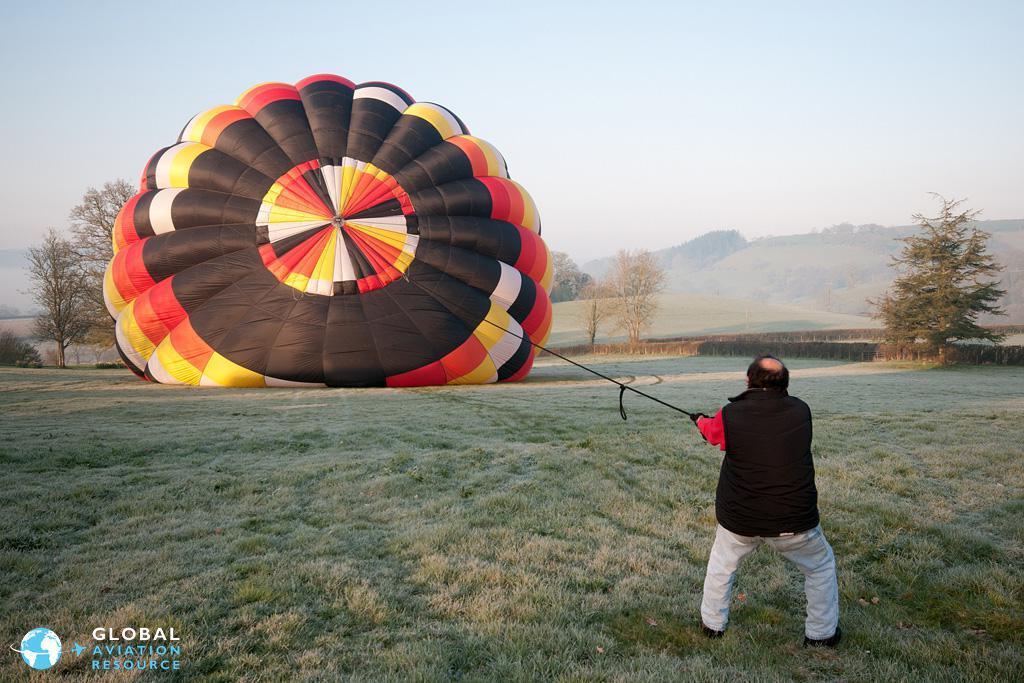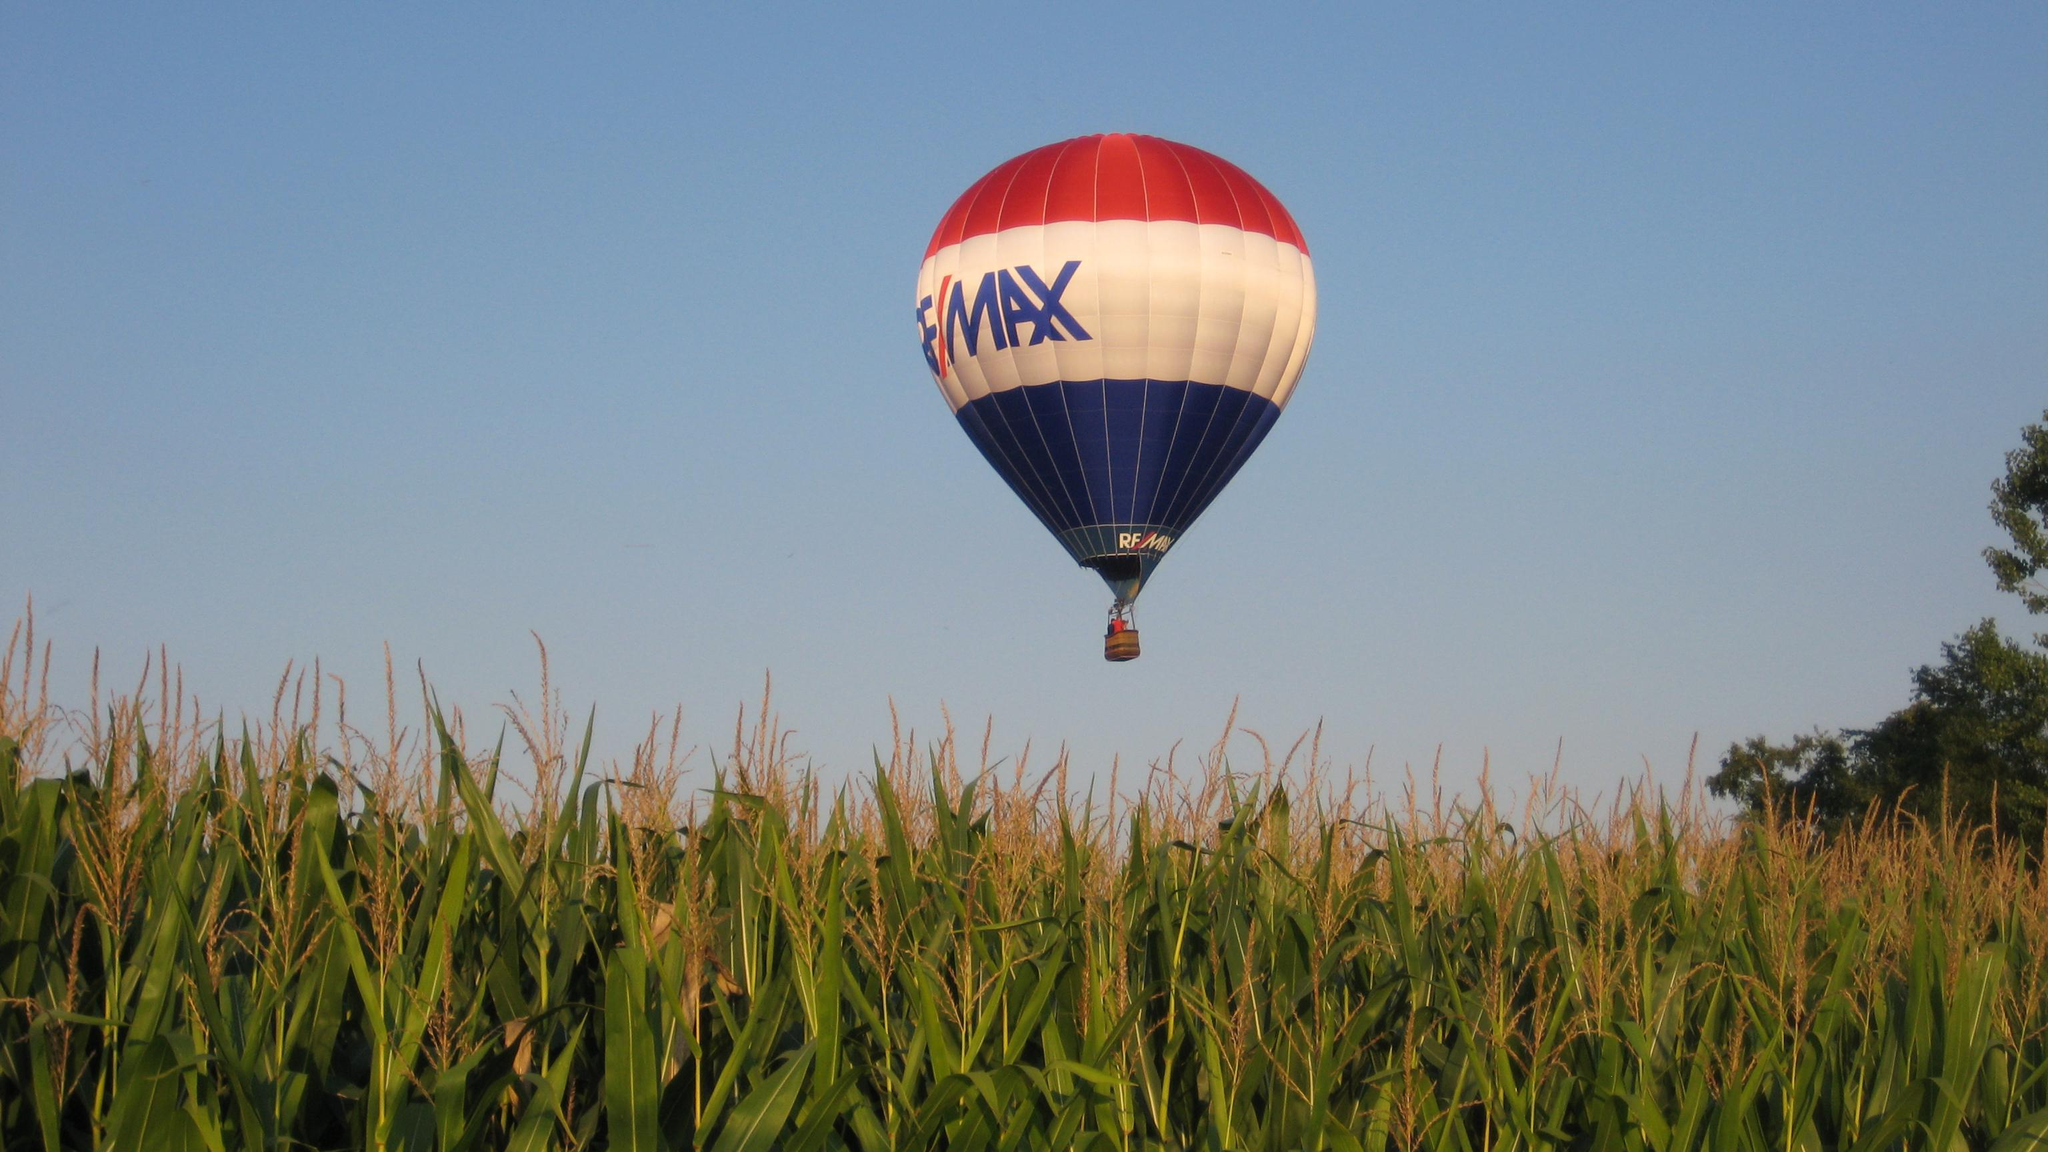The first image is the image on the left, the second image is the image on the right. Given the left and right images, does the statement "An image shows a solid-red balloon floating above a green field." hold true? Answer yes or no. No. The first image is the image on the left, the second image is the image on the right. Evaluate the accuracy of this statement regarding the images: "The balloon is in the air in the image on the left.". Is it true? Answer yes or no. No. 